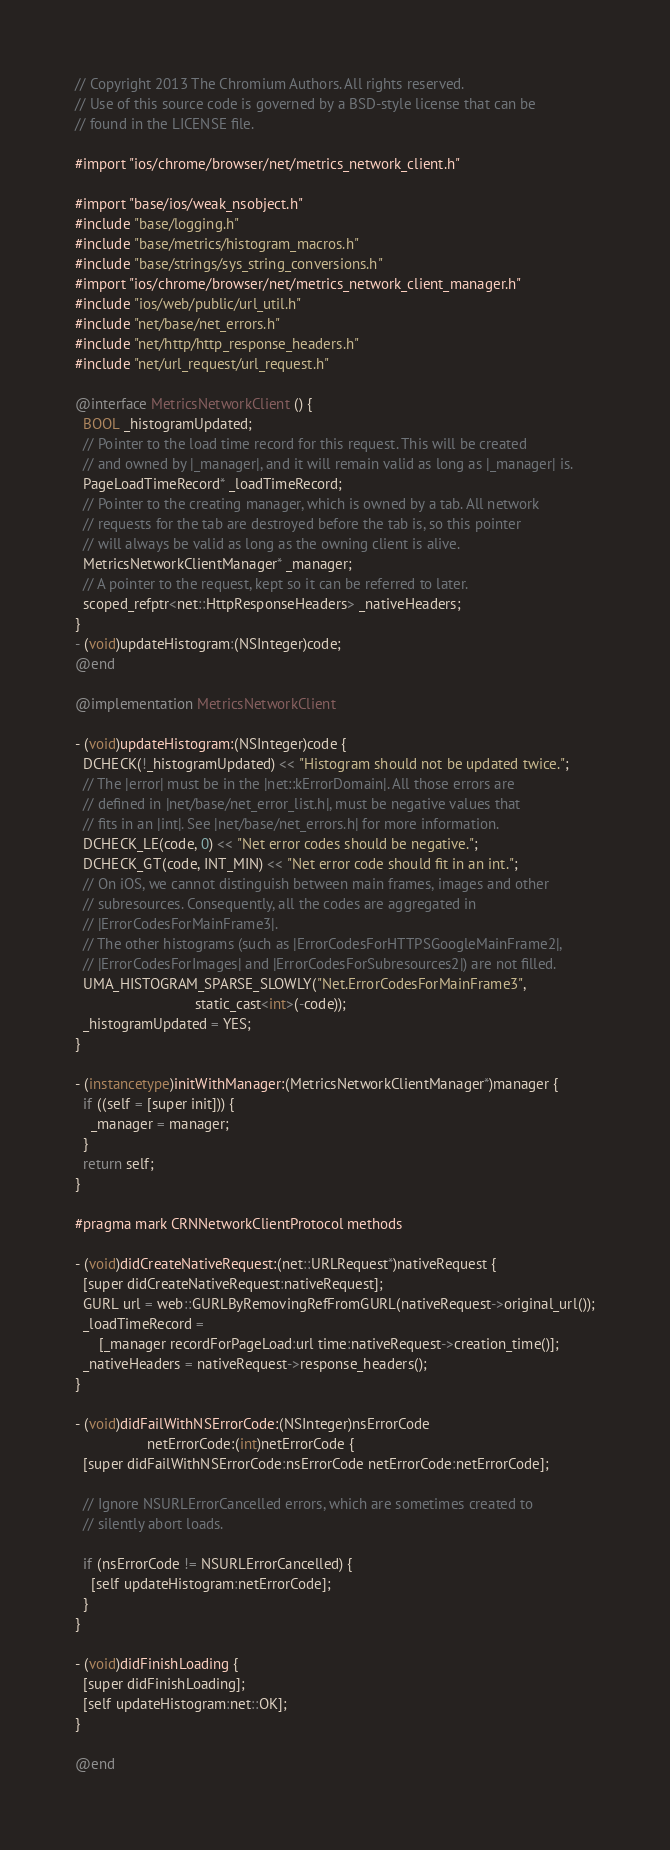Convert code to text. <code><loc_0><loc_0><loc_500><loc_500><_ObjectiveC_>// Copyright 2013 The Chromium Authors. All rights reserved.
// Use of this source code is governed by a BSD-style license that can be
// found in the LICENSE file.

#import "ios/chrome/browser/net/metrics_network_client.h"

#import "base/ios/weak_nsobject.h"
#include "base/logging.h"
#include "base/metrics/histogram_macros.h"
#include "base/strings/sys_string_conversions.h"
#import "ios/chrome/browser/net/metrics_network_client_manager.h"
#include "ios/web/public/url_util.h"
#include "net/base/net_errors.h"
#include "net/http/http_response_headers.h"
#include "net/url_request/url_request.h"

@interface MetricsNetworkClient () {
  BOOL _histogramUpdated;
  // Pointer to the load time record for this request. This will be created
  // and owned by |_manager|, and it will remain valid as long as |_manager| is.
  PageLoadTimeRecord* _loadTimeRecord;
  // Pointer to the creating manager, which is owned by a tab. All network
  // requests for the tab are destroyed before the tab is, so this pointer
  // will always be valid as long as the owning client is alive.
  MetricsNetworkClientManager* _manager;
  // A pointer to the request, kept so it can be referred to later.
  scoped_refptr<net::HttpResponseHeaders> _nativeHeaders;
}
- (void)updateHistogram:(NSInteger)code;
@end

@implementation MetricsNetworkClient

- (void)updateHistogram:(NSInteger)code {
  DCHECK(!_histogramUpdated) << "Histogram should not be updated twice.";
  // The |error| must be in the |net::kErrorDomain|. All those errors are
  // defined in |net/base/net_error_list.h|, must be negative values that
  // fits in an |int|. See |net/base/net_errors.h| for more information.
  DCHECK_LE(code, 0) << "Net error codes should be negative.";
  DCHECK_GT(code, INT_MIN) << "Net error code should fit in an int.";
  // On iOS, we cannot distinguish between main frames, images and other
  // subresources. Consequently, all the codes are aggregated in
  // |ErrorCodesForMainFrame3|.
  // The other histograms (such as |ErrorCodesForHTTPSGoogleMainFrame2|,
  // |ErrorCodesForImages| and |ErrorCodesForSubresources2|) are not filled.
  UMA_HISTOGRAM_SPARSE_SLOWLY("Net.ErrorCodesForMainFrame3",
                              static_cast<int>(-code));
  _histogramUpdated = YES;
}

- (instancetype)initWithManager:(MetricsNetworkClientManager*)manager {
  if ((self = [super init])) {
    _manager = manager;
  }
  return self;
}

#pragma mark CRNNetworkClientProtocol methods

- (void)didCreateNativeRequest:(net::URLRequest*)nativeRequest {
  [super didCreateNativeRequest:nativeRequest];
  GURL url = web::GURLByRemovingRefFromGURL(nativeRequest->original_url());
  _loadTimeRecord =
      [_manager recordForPageLoad:url time:nativeRequest->creation_time()];
  _nativeHeaders = nativeRequest->response_headers();
}

- (void)didFailWithNSErrorCode:(NSInteger)nsErrorCode
                  netErrorCode:(int)netErrorCode {
  [super didFailWithNSErrorCode:nsErrorCode netErrorCode:netErrorCode];

  // Ignore NSURLErrorCancelled errors, which are sometimes created to
  // silently abort loads.

  if (nsErrorCode != NSURLErrorCancelled) {
    [self updateHistogram:netErrorCode];
  }
}

- (void)didFinishLoading {
  [super didFinishLoading];
  [self updateHistogram:net::OK];
}

@end
</code> 